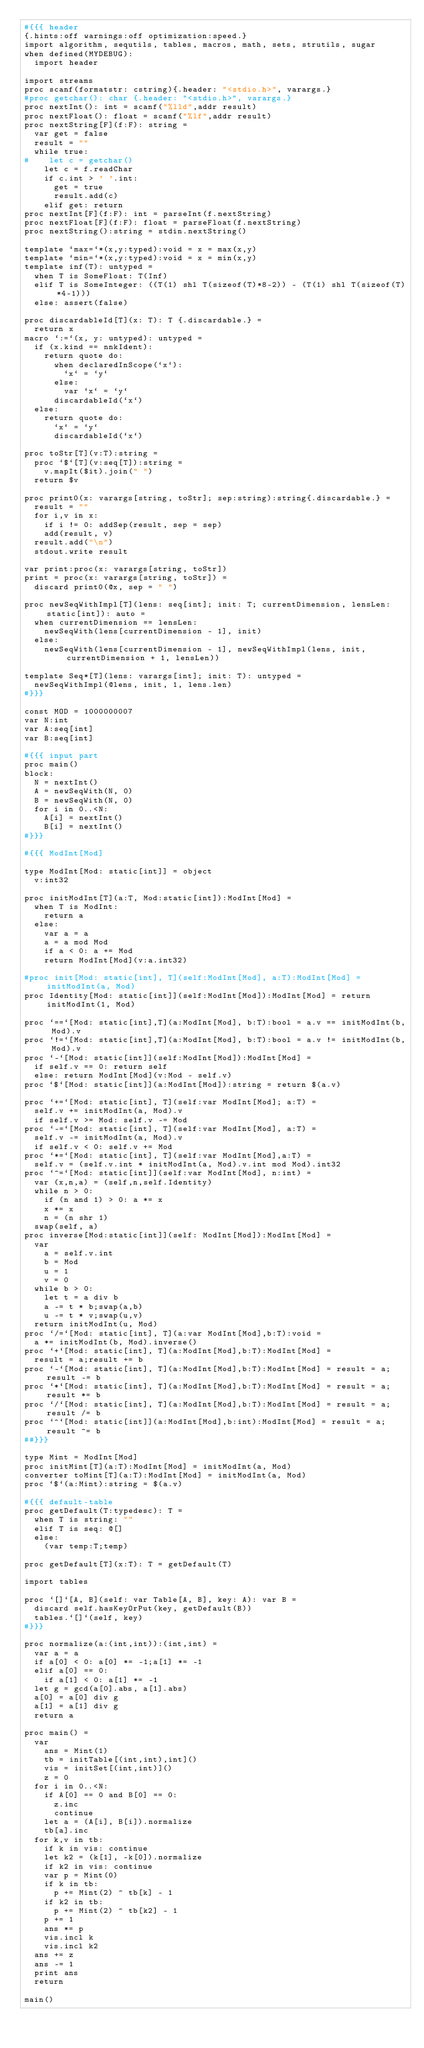<code> <loc_0><loc_0><loc_500><loc_500><_Nim_>#{{{ header
{.hints:off warnings:off optimization:speed.}
import algorithm, sequtils, tables, macros, math, sets, strutils, sugar
when defined(MYDEBUG):
  import header

import streams
proc scanf(formatstr: cstring){.header: "<stdio.h>", varargs.}
#proc getchar(): char {.header: "<stdio.h>", varargs.}
proc nextInt(): int = scanf("%lld",addr result)
proc nextFloat(): float = scanf("%lf",addr result)
proc nextString[F](f:F): string =
  var get = false
  result = ""
  while true:
#    let c = getchar()
    let c = f.readChar
    if c.int > ' '.int:
      get = true
      result.add(c)
    elif get: return
proc nextInt[F](f:F): int = parseInt(f.nextString)
proc nextFloat[F](f:F): float = parseFloat(f.nextString)
proc nextString():string = stdin.nextString()

template `max=`*(x,y:typed):void = x = max(x,y)
template `min=`*(x,y:typed):void = x = min(x,y)
template inf(T): untyped = 
  when T is SomeFloat: T(Inf)
  elif T is SomeInteger: ((T(1) shl T(sizeof(T)*8-2)) - (T(1) shl T(sizeof(T)*4-1)))
  else: assert(false)

proc discardableId[T](x: T): T {.discardable.} =
  return x
macro `:=`(x, y: untyped): untyped =
  if (x.kind == nnkIdent):
    return quote do:
      when declaredInScope(`x`):
        `x` = `y`
      else:
        var `x` = `y`
      discardableId(`x`)
  else:
    return quote do:
      `x` = `y`
      discardableId(`x`)

proc toStr[T](v:T):string =
  proc `$`[T](v:seq[T]):string =
    v.mapIt($it).join(" ")
  return $v

proc print0(x: varargs[string, toStr]; sep:string):string{.discardable.} =
  result = ""
  for i,v in x:
    if i != 0: addSep(result, sep = sep)
    add(result, v)
  result.add("\n")
  stdout.write result

var print:proc(x: varargs[string, toStr])
print = proc(x: varargs[string, toStr]) =
  discard print0(@x, sep = " ")

proc newSeqWithImpl[T](lens: seq[int]; init: T; currentDimension, lensLen: static[int]): auto =
  when currentDimension == lensLen:
    newSeqWith(lens[currentDimension - 1], init)
  else:
    newSeqWith(lens[currentDimension - 1], newSeqWithImpl(lens, init, currentDimension + 1, lensLen))

template Seq*[T](lens: varargs[int]; init: T): untyped =
  newSeqWithImpl(@lens, init, 1, lens.len)
#}}}

const MOD = 1000000007
var N:int
var A:seq[int]
var B:seq[int]

#{{{ input part
proc main()
block:
  N = nextInt()
  A = newSeqWith(N, 0)
  B = newSeqWith(N, 0)
  for i in 0..<N:
    A[i] = nextInt()
    B[i] = nextInt()
#}}}

#{{{ ModInt[Mod]

type ModInt[Mod: static[int]] = object
  v:int32

proc initModInt[T](a:T, Mod:static[int]):ModInt[Mod] =
  when T is ModInt:
    return a
  else:
    var a = a
    a = a mod Mod
    if a < 0: a += Mod
    return ModInt[Mod](v:a.int32)

#proc init[Mod: static[int], T](self:ModInt[Mod], a:T):ModInt[Mod] = initModInt(a, Mod)
proc Identity[Mod: static[int]](self:ModInt[Mod]):ModInt[Mod] = return initModInt(1, Mod)

proc `==`[Mod: static[int],T](a:ModInt[Mod], b:T):bool = a.v == initModInt(b, Mod).v
proc `!=`[Mod: static[int],T](a:ModInt[Mod], b:T):bool = a.v != initModInt(b, Mod).v
proc `-`[Mod: static[int]](self:ModInt[Mod]):ModInt[Mod] =
  if self.v == 0: return self
  else: return ModInt[Mod](v:Mod - self.v)
proc `$`[Mod: static[int]](a:ModInt[Mod]):string = return $(a.v)

proc `+=`[Mod: static[int], T](self:var ModInt[Mod]; a:T) =
  self.v += initModInt(a, Mod).v
  if self.v >= Mod: self.v -= Mod
proc `-=`[Mod: static[int], T](self:var ModInt[Mod], a:T) =
  self.v -= initModInt(a, Mod).v
  if self.v < 0: self.v += Mod
proc `*=`[Mod: static[int], T](self:var ModInt[Mod],a:T) =
  self.v = (self.v.int * initModInt(a, Mod).v.int mod Mod).int32
proc `^=`[Mod: static[int]](self:var ModInt[Mod], n:int) =
  var (x,n,a) = (self,n,self.Identity)
  while n > 0:
    if (n and 1) > 0: a *= x
    x *= x
    n = (n shr 1)
  swap(self, a)
proc inverse[Mod:static[int]](self: ModInt[Mod]):ModInt[Mod] =
  var
    a = self.v.int
    b = Mod
    u = 1
    v = 0
  while b > 0:
    let t = a div b
    a -= t * b;swap(a,b)
    u -= t * v;swap(u,v)
  return initModInt(u, Mod)
proc `/=`[Mod: static[int], T](a:var ModInt[Mod],b:T):void =
  a *= initModInt(b, Mod).inverse()
proc `+`[Mod: static[int], T](a:ModInt[Mod],b:T):ModInt[Mod] = 
  result = a;result += b
proc `-`[Mod: static[int], T](a:ModInt[Mod],b:T):ModInt[Mod] = result = a;result -= b
proc `*`[Mod: static[int], T](a:ModInt[Mod],b:T):ModInt[Mod] = result = a;result *= b
proc `/`[Mod: static[int], T](a:ModInt[Mod],b:T):ModInt[Mod] = result = a; result /= b
proc `^`[Mod: static[int]](a:ModInt[Mod],b:int):ModInt[Mod] = result = a; result ^= b
##}}}

type Mint = ModInt[Mod]
proc initMint[T](a:T):ModInt[Mod] = initModInt(a, Mod)
converter toMint[T](a:T):ModInt[Mod] = initModInt(a, Mod)
proc `$`(a:Mint):string = $(a.v)

#{{{ default-table
proc getDefault(T:typedesc): T =
  when T is string: ""
  elif T is seq: @[]
  else:
    (var temp:T;temp)

proc getDefault[T](x:T): T = getDefault(T)

import tables

proc `[]`[A, B](self: var Table[A, B], key: A): var B =
  discard self.hasKeyOrPut(key, getDefault(B))
  tables.`[]`(self, key)
#}}}

proc normalize(a:(int,int)):(int,int) =
  var a = a
  if a[0] < 0: a[0] *= -1;a[1] *= -1
  elif a[0] == 0:
    if a[1] < 0: a[1] *= -1
  let g = gcd(a[0].abs, a[1].abs)
  a[0] = a[0] div g
  a[1] = a[1] div g
  return a

proc main() =
  var
    ans = Mint(1)
    tb = initTable[(int,int),int]()
    vis = initSet[(int,int)]()
    z = 0
  for i in 0..<N:
    if A[0] == 0 and B[0] == 0:
      z.inc
      continue
    let a = (A[i], B[i]).normalize
    tb[a].inc
  for k,v in tb:
    if k in vis: continue
    let k2 = (k[1], -k[0]).normalize
    if k2 in vis: continue
    var p = Mint(0)
    if k in tb:
      p += Mint(2) ^ tb[k] - 1
    if k2 in tb:
      p += Mint(2) ^ tb[k2] - 1
    p += 1
    ans *= p
    vis.incl k
    vis.incl k2
  ans += z
  ans -= 1
  print ans
  return

main()
</code> 